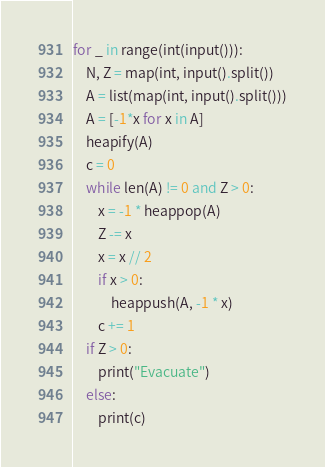Convert code to text. <code><loc_0><loc_0><loc_500><loc_500><_Python_>for _ in range(int(input())):
    N, Z = map(int, input().split())
    A = list(map(int, input().split()))
    A = [-1*x for x in A]
    heapify(A)
    c = 0
    while len(A) != 0 and Z > 0:
        x = -1 * heappop(A)
        Z -= x
        x = x // 2
        if x > 0:
            heappush(A, -1 * x)
        c += 1
    if Z > 0: 
        print("Evacuate")
    else: 
        print(c)
</code> 